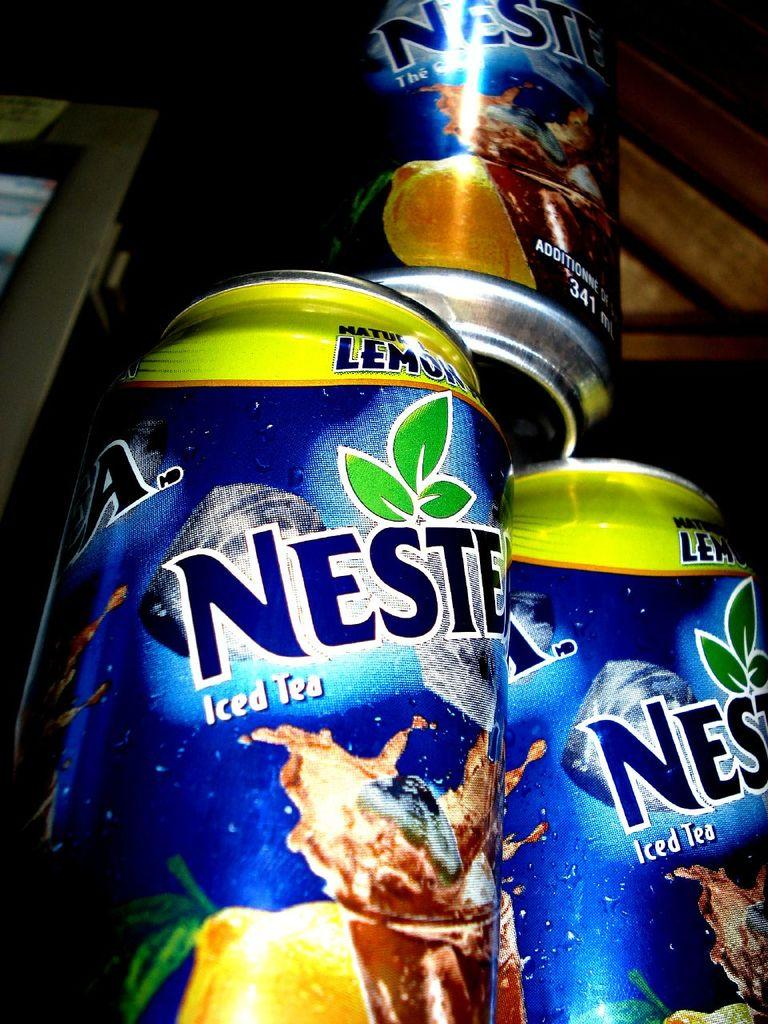<image>
Share a concise interpretation of the image provided. Cans of Nestea iced tea are stacked up. 